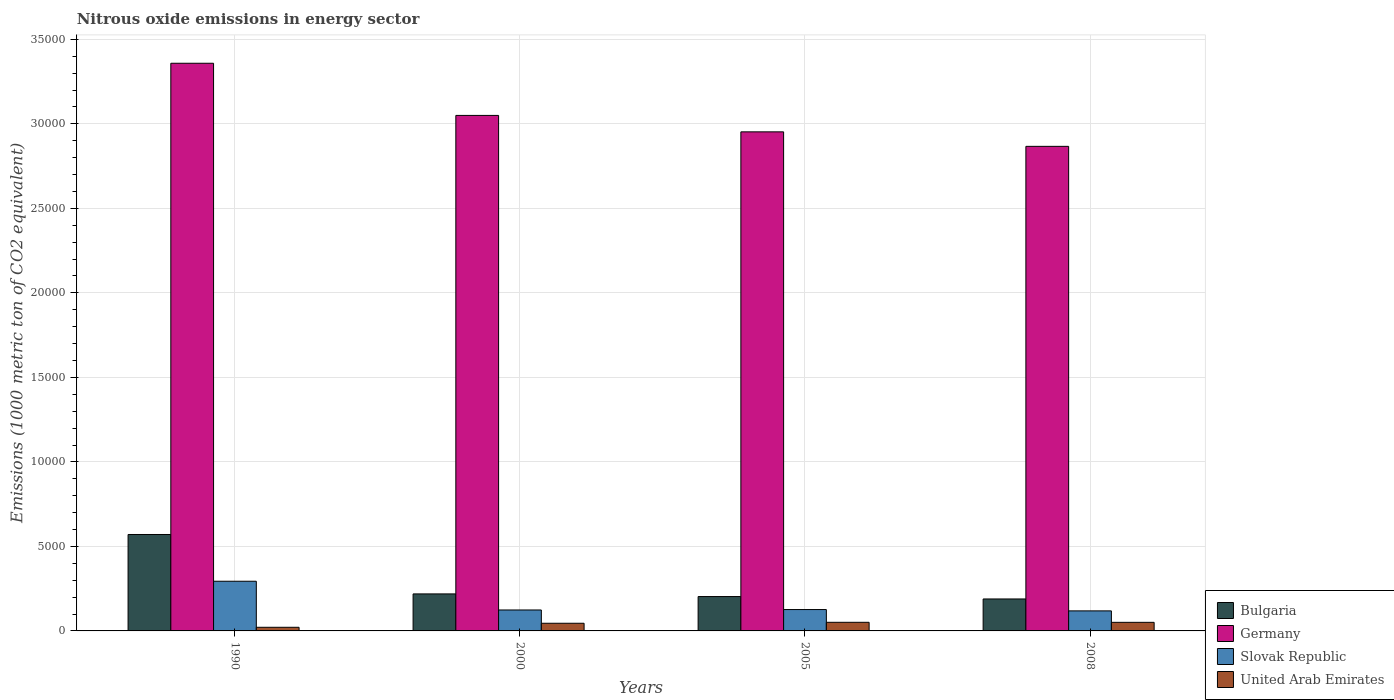How many bars are there on the 2nd tick from the right?
Provide a short and direct response. 4. What is the label of the 2nd group of bars from the left?
Provide a succinct answer. 2000. What is the amount of nitrous oxide emitted in United Arab Emirates in 2008?
Provide a short and direct response. 507.7. Across all years, what is the maximum amount of nitrous oxide emitted in Germany?
Your answer should be compact. 3.36e+04. Across all years, what is the minimum amount of nitrous oxide emitted in Slovak Republic?
Your answer should be compact. 1185.5. In which year was the amount of nitrous oxide emitted in United Arab Emirates maximum?
Provide a short and direct response. 2005. In which year was the amount of nitrous oxide emitted in Bulgaria minimum?
Ensure brevity in your answer.  2008. What is the total amount of nitrous oxide emitted in United Arab Emirates in the graph?
Provide a short and direct response. 1686. What is the difference between the amount of nitrous oxide emitted in Bulgaria in 1990 and that in 2008?
Your answer should be very brief. 3814.8. What is the difference between the amount of nitrous oxide emitted in United Arab Emirates in 2008 and the amount of nitrous oxide emitted in Slovak Republic in 2005?
Give a very brief answer. -756.8. What is the average amount of nitrous oxide emitted in United Arab Emirates per year?
Your answer should be very brief. 421.5. In the year 2005, what is the difference between the amount of nitrous oxide emitted in Bulgaria and amount of nitrous oxide emitted in Germany?
Offer a very short reply. -2.75e+04. In how many years, is the amount of nitrous oxide emitted in Germany greater than 10000 1000 metric ton?
Your answer should be compact. 4. What is the ratio of the amount of nitrous oxide emitted in Slovak Republic in 2000 to that in 2005?
Keep it short and to the point. 0.98. Is the amount of nitrous oxide emitted in United Arab Emirates in 1990 less than that in 2005?
Your answer should be very brief. Yes. What is the difference between the highest and the second highest amount of nitrous oxide emitted in United Arab Emirates?
Ensure brevity in your answer.  2.5. What is the difference between the highest and the lowest amount of nitrous oxide emitted in Bulgaria?
Your answer should be compact. 3814.8. In how many years, is the amount of nitrous oxide emitted in Slovak Republic greater than the average amount of nitrous oxide emitted in Slovak Republic taken over all years?
Your answer should be compact. 1. Is the sum of the amount of nitrous oxide emitted in United Arab Emirates in 2005 and 2008 greater than the maximum amount of nitrous oxide emitted in Bulgaria across all years?
Keep it short and to the point. No. What does the 3rd bar from the left in 2005 represents?
Offer a terse response. Slovak Republic. What does the 3rd bar from the right in 2008 represents?
Provide a short and direct response. Germany. Are all the bars in the graph horizontal?
Ensure brevity in your answer.  No. What is the difference between two consecutive major ticks on the Y-axis?
Give a very brief answer. 5000. Does the graph contain any zero values?
Ensure brevity in your answer.  No. Does the graph contain grids?
Ensure brevity in your answer.  Yes. Where does the legend appear in the graph?
Ensure brevity in your answer.  Bottom right. How many legend labels are there?
Offer a terse response. 4. What is the title of the graph?
Offer a terse response. Nitrous oxide emissions in energy sector. What is the label or title of the X-axis?
Provide a short and direct response. Years. What is the label or title of the Y-axis?
Provide a succinct answer. Emissions (1000 metric ton of CO2 equivalent). What is the Emissions (1000 metric ton of CO2 equivalent) of Bulgaria in 1990?
Make the answer very short. 5705.4. What is the Emissions (1000 metric ton of CO2 equivalent) in Germany in 1990?
Ensure brevity in your answer.  3.36e+04. What is the Emissions (1000 metric ton of CO2 equivalent) of Slovak Republic in 1990?
Give a very brief answer. 2939.5. What is the Emissions (1000 metric ton of CO2 equivalent) in United Arab Emirates in 1990?
Provide a short and direct response. 214.5. What is the Emissions (1000 metric ton of CO2 equivalent) in Bulgaria in 2000?
Give a very brief answer. 2189.9. What is the Emissions (1000 metric ton of CO2 equivalent) of Germany in 2000?
Keep it short and to the point. 3.05e+04. What is the Emissions (1000 metric ton of CO2 equivalent) in Slovak Republic in 2000?
Keep it short and to the point. 1239.1. What is the Emissions (1000 metric ton of CO2 equivalent) in United Arab Emirates in 2000?
Your answer should be very brief. 453.6. What is the Emissions (1000 metric ton of CO2 equivalent) in Bulgaria in 2005?
Make the answer very short. 2033.5. What is the Emissions (1000 metric ton of CO2 equivalent) of Germany in 2005?
Offer a very short reply. 2.95e+04. What is the Emissions (1000 metric ton of CO2 equivalent) in Slovak Republic in 2005?
Ensure brevity in your answer.  1264.5. What is the Emissions (1000 metric ton of CO2 equivalent) in United Arab Emirates in 2005?
Provide a succinct answer. 510.2. What is the Emissions (1000 metric ton of CO2 equivalent) of Bulgaria in 2008?
Keep it short and to the point. 1890.6. What is the Emissions (1000 metric ton of CO2 equivalent) of Germany in 2008?
Make the answer very short. 2.87e+04. What is the Emissions (1000 metric ton of CO2 equivalent) of Slovak Republic in 2008?
Offer a very short reply. 1185.5. What is the Emissions (1000 metric ton of CO2 equivalent) of United Arab Emirates in 2008?
Keep it short and to the point. 507.7. Across all years, what is the maximum Emissions (1000 metric ton of CO2 equivalent) of Bulgaria?
Give a very brief answer. 5705.4. Across all years, what is the maximum Emissions (1000 metric ton of CO2 equivalent) in Germany?
Keep it short and to the point. 3.36e+04. Across all years, what is the maximum Emissions (1000 metric ton of CO2 equivalent) in Slovak Republic?
Give a very brief answer. 2939.5. Across all years, what is the maximum Emissions (1000 metric ton of CO2 equivalent) of United Arab Emirates?
Offer a terse response. 510.2. Across all years, what is the minimum Emissions (1000 metric ton of CO2 equivalent) of Bulgaria?
Keep it short and to the point. 1890.6. Across all years, what is the minimum Emissions (1000 metric ton of CO2 equivalent) of Germany?
Your answer should be very brief. 2.87e+04. Across all years, what is the minimum Emissions (1000 metric ton of CO2 equivalent) of Slovak Republic?
Your answer should be compact. 1185.5. Across all years, what is the minimum Emissions (1000 metric ton of CO2 equivalent) of United Arab Emirates?
Make the answer very short. 214.5. What is the total Emissions (1000 metric ton of CO2 equivalent) of Bulgaria in the graph?
Offer a terse response. 1.18e+04. What is the total Emissions (1000 metric ton of CO2 equivalent) of Germany in the graph?
Offer a very short reply. 1.22e+05. What is the total Emissions (1000 metric ton of CO2 equivalent) of Slovak Republic in the graph?
Offer a very short reply. 6628.6. What is the total Emissions (1000 metric ton of CO2 equivalent) in United Arab Emirates in the graph?
Provide a short and direct response. 1686. What is the difference between the Emissions (1000 metric ton of CO2 equivalent) of Bulgaria in 1990 and that in 2000?
Your answer should be very brief. 3515.5. What is the difference between the Emissions (1000 metric ton of CO2 equivalent) in Germany in 1990 and that in 2000?
Make the answer very short. 3086.2. What is the difference between the Emissions (1000 metric ton of CO2 equivalent) of Slovak Republic in 1990 and that in 2000?
Ensure brevity in your answer.  1700.4. What is the difference between the Emissions (1000 metric ton of CO2 equivalent) of United Arab Emirates in 1990 and that in 2000?
Provide a short and direct response. -239.1. What is the difference between the Emissions (1000 metric ton of CO2 equivalent) of Bulgaria in 1990 and that in 2005?
Your answer should be compact. 3671.9. What is the difference between the Emissions (1000 metric ton of CO2 equivalent) in Germany in 1990 and that in 2005?
Your answer should be very brief. 4058.7. What is the difference between the Emissions (1000 metric ton of CO2 equivalent) of Slovak Republic in 1990 and that in 2005?
Provide a short and direct response. 1675. What is the difference between the Emissions (1000 metric ton of CO2 equivalent) in United Arab Emirates in 1990 and that in 2005?
Your answer should be compact. -295.7. What is the difference between the Emissions (1000 metric ton of CO2 equivalent) of Bulgaria in 1990 and that in 2008?
Make the answer very short. 3814.8. What is the difference between the Emissions (1000 metric ton of CO2 equivalent) of Germany in 1990 and that in 2008?
Give a very brief answer. 4916.5. What is the difference between the Emissions (1000 metric ton of CO2 equivalent) of Slovak Republic in 1990 and that in 2008?
Ensure brevity in your answer.  1754. What is the difference between the Emissions (1000 metric ton of CO2 equivalent) of United Arab Emirates in 1990 and that in 2008?
Ensure brevity in your answer.  -293.2. What is the difference between the Emissions (1000 metric ton of CO2 equivalent) of Bulgaria in 2000 and that in 2005?
Ensure brevity in your answer.  156.4. What is the difference between the Emissions (1000 metric ton of CO2 equivalent) of Germany in 2000 and that in 2005?
Offer a terse response. 972.5. What is the difference between the Emissions (1000 metric ton of CO2 equivalent) of Slovak Republic in 2000 and that in 2005?
Your answer should be compact. -25.4. What is the difference between the Emissions (1000 metric ton of CO2 equivalent) in United Arab Emirates in 2000 and that in 2005?
Give a very brief answer. -56.6. What is the difference between the Emissions (1000 metric ton of CO2 equivalent) in Bulgaria in 2000 and that in 2008?
Offer a terse response. 299.3. What is the difference between the Emissions (1000 metric ton of CO2 equivalent) in Germany in 2000 and that in 2008?
Offer a very short reply. 1830.3. What is the difference between the Emissions (1000 metric ton of CO2 equivalent) in Slovak Republic in 2000 and that in 2008?
Ensure brevity in your answer.  53.6. What is the difference between the Emissions (1000 metric ton of CO2 equivalent) of United Arab Emirates in 2000 and that in 2008?
Your answer should be compact. -54.1. What is the difference between the Emissions (1000 metric ton of CO2 equivalent) of Bulgaria in 2005 and that in 2008?
Provide a succinct answer. 142.9. What is the difference between the Emissions (1000 metric ton of CO2 equivalent) in Germany in 2005 and that in 2008?
Make the answer very short. 857.8. What is the difference between the Emissions (1000 metric ton of CO2 equivalent) in Slovak Republic in 2005 and that in 2008?
Ensure brevity in your answer.  79. What is the difference between the Emissions (1000 metric ton of CO2 equivalent) of Bulgaria in 1990 and the Emissions (1000 metric ton of CO2 equivalent) of Germany in 2000?
Your answer should be compact. -2.48e+04. What is the difference between the Emissions (1000 metric ton of CO2 equivalent) in Bulgaria in 1990 and the Emissions (1000 metric ton of CO2 equivalent) in Slovak Republic in 2000?
Keep it short and to the point. 4466.3. What is the difference between the Emissions (1000 metric ton of CO2 equivalent) of Bulgaria in 1990 and the Emissions (1000 metric ton of CO2 equivalent) of United Arab Emirates in 2000?
Ensure brevity in your answer.  5251.8. What is the difference between the Emissions (1000 metric ton of CO2 equivalent) of Germany in 1990 and the Emissions (1000 metric ton of CO2 equivalent) of Slovak Republic in 2000?
Make the answer very short. 3.23e+04. What is the difference between the Emissions (1000 metric ton of CO2 equivalent) in Germany in 1990 and the Emissions (1000 metric ton of CO2 equivalent) in United Arab Emirates in 2000?
Your answer should be very brief. 3.31e+04. What is the difference between the Emissions (1000 metric ton of CO2 equivalent) in Slovak Republic in 1990 and the Emissions (1000 metric ton of CO2 equivalent) in United Arab Emirates in 2000?
Your answer should be very brief. 2485.9. What is the difference between the Emissions (1000 metric ton of CO2 equivalent) of Bulgaria in 1990 and the Emissions (1000 metric ton of CO2 equivalent) of Germany in 2005?
Make the answer very short. -2.38e+04. What is the difference between the Emissions (1000 metric ton of CO2 equivalent) of Bulgaria in 1990 and the Emissions (1000 metric ton of CO2 equivalent) of Slovak Republic in 2005?
Your answer should be very brief. 4440.9. What is the difference between the Emissions (1000 metric ton of CO2 equivalent) of Bulgaria in 1990 and the Emissions (1000 metric ton of CO2 equivalent) of United Arab Emirates in 2005?
Offer a very short reply. 5195.2. What is the difference between the Emissions (1000 metric ton of CO2 equivalent) of Germany in 1990 and the Emissions (1000 metric ton of CO2 equivalent) of Slovak Republic in 2005?
Your response must be concise. 3.23e+04. What is the difference between the Emissions (1000 metric ton of CO2 equivalent) of Germany in 1990 and the Emissions (1000 metric ton of CO2 equivalent) of United Arab Emirates in 2005?
Offer a terse response. 3.31e+04. What is the difference between the Emissions (1000 metric ton of CO2 equivalent) of Slovak Republic in 1990 and the Emissions (1000 metric ton of CO2 equivalent) of United Arab Emirates in 2005?
Make the answer very short. 2429.3. What is the difference between the Emissions (1000 metric ton of CO2 equivalent) in Bulgaria in 1990 and the Emissions (1000 metric ton of CO2 equivalent) in Germany in 2008?
Provide a short and direct response. -2.30e+04. What is the difference between the Emissions (1000 metric ton of CO2 equivalent) of Bulgaria in 1990 and the Emissions (1000 metric ton of CO2 equivalent) of Slovak Republic in 2008?
Give a very brief answer. 4519.9. What is the difference between the Emissions (1000 metric ton of CO2 equivalent) of Bulgaria in 1990 and the Emissions (1000 metric ton of CO2 equivalent) of United Arab Emirates in 2008?
Ensure brevity in your answer.  5197.7. What is the difference between the Emissions (1000 metric ton of CO2 equivalent) of Germany in 1990 and the Emissions (1000 metric ton of CO2 equivalent) of Slovak Republic in 2008?
Offer a terse response. 3.24e+04. What is the difference between the Emissions (1000 metric ton of CO2 equivalent) of Germany in 1990 and the Emissions (1000 metric ton of CO2 equivalent) of United Arab Emirates in 2008?
Make the answer very short. 3.31e+04. What is the difference between the Emissions (1000 metric ton of CO2 equivalent) in Slovak Republic in 1990 and the Emissions (1000 metric ton of CO2 equivalent) in United Arab Emirates in 2008?
Give a very brief answer. 2431.8. What is the difference between the Emissions (1000 metric ton of CO2 equivalent) in Bulgaria in 2000 and the Emissions (1000 metric ton of CO2 equivalent) in Germany in 2005?
Offer a very short reply. -2.73e+04. What is the difference between the Emissions (1000 metric ton of CO2 equivalent) of Bulgaria in 2000 and the Emissions (1000 metric ton of CO2 equivalent) of Slovak Republic in 2005?
Ensure brevity in your answer.  925.4. What is the difference between the Emissions (1000 metric ton of CO2 equivalent) of Bulgaria in 2000 and the Emissions (1000 metric ton of CO2 equivalent) of United Arab Emirates in 2005?
Give a very brief answer. 1679.7. What is the difference between the Emissions (1000 metric ton of CO2 equivalent) in Germany in 2000 and the Emissions (1000 metric ton of CO2 equivalent) in Slovak Republic in 2005?
Give a very brief answer. 2.92e+04. What is the difference between the Emissions (1000 metric ton of CO2 equivalent) of Germany in 2000 and the Emissions (1000 metric ton of CO2 equivalent) of United Arab Emirates in 2005?
Offer a very short reply. 3.00e+04. What is the difference between the Emissions (1000 metric ton of CO2 equivalent) of Slovak Republic in 2000 and the Emissions (1000 metric ton of CO2 equivalent) of United Arab Emirates in 2005?
Keep it short and to the point. 728.9. What is the difference between the Emissions (1000 metric ton of CO2 equivalent) in Bulgaria in 2000 and the Emissions (1000 metric ton of CO2 equivalent) in Germany in 2008?
Your answer should be compact. -2.65e+04. What is the difference between the Emissions (1000 metric ton of CO2 equivalent) in Bulgaria in 2000 and the Emissions (1000 metric ton of CO2 equivalent) in Slovak Republic in 2008?
Provide a succinct answer. 1004.4. What is the difference between the Emissions (1000 metric ton of CO2 equivalent) of Bulgaria in 2000 and the Emissions (1000 metric ton of CO2 equivalent) of United Arab Emirates in 2008?
Make the answer very short. 1682.2. What is the difference between the Emissions (1000 metric ton of CO2 equivalent) of Germany in 2000 and the Emissions (1000 metric ton of CO2 equivalent) of Slovak Republic in 2008?
Your answer should be very brief. 2.93e+04. What is the difference between the Emissions (1000 metric ton of CO2 equivalent) in Germany in 2000 and the Emissions (1000 metric ton of CO2 equivalent) in United Arab Emirates in 2008?
Provide a short and direct response. 3.00e+04. What is the difference between the Emissions (1000 metric ton of CO2 equivalent) in Slovak Republic in 2000 and the Emissions (1000 metric ton of CO2 equivalent) in United Arab Emirates in 2008?
Your answer should be compact. 731.4. What is the difference between the Emissions (1000 metric ton of CO2 equivalent) of Bulgaria in 2005 and the Emissions (1000 metric ton of CO2 equivalent) of Germany in 2008?
Keep it short and to the point. -2.66e+04. What is the difference between the Emissions (1000 metric ton of CO2 equivalent) in Bulgaria in 2005 and the Emissions (1000 metric ton of CO2 equivalent) in Slovak Republic in 2008?
Ensure brevity in your answer.  848. What is the difference between the Emissions (1000 metric ton of CO2 equivalent) of Bulgaria in 2005 and the Emissions (1000 metric ton of CO2 equivalent) of United Arab Emirates in 2008?
Offer a very short reply. 1525.8. What is the difference between the Emissions (1000 metric ton of CO2 equivalent) of Germany in 2005 and the Emissions (1000 metric ton of CO2 equivalent) of Slovak Republic in 2008?
Ensure brevity in your answer.  2.83e+04. What is the difference between the Emissions (1000 metric ton of CO2 equivalent) in Germany in 2005 and the Emissions (1000 metric ton of CO2 equivalent) in United Arab Emirates in 2008?
Keep it short and to the point. 2.90e+04. What is the difference between the Emissions (1000 metric ton of CO2 equivalent) in Slovak Republic in 2005 and the Emissions (1000 metric ton of CO2 equivalent) in United Arab Emirates in 2008?
Give a very brief answer. 756.8. What is the average Emissions (1000 metric ton of CO2 equivalent) in Bulgaria per year?
Keep it short and to the point. 2954.85. What is the average Emissions (1000 metric ton of CO2 equivalent) in Germany per year?
Make the answer very short. 3.06e+04. What is the average Emissions (1000 metric ton of CO2 equivalent) in Slovak Republic per year?
Provide a succinct answer. 1657.15. What is the average Emissions (1000 metric ton of CO2 equivalent) of United Arab Emirates per year?
Provide a short and direct response. 421.5. In the year 1990, what is the difference between the Emissions (1000 metric ton of CO2 equivalent) in Bulgaria and Emissions (1000 metric ton of CO2 equivalent) in Germany?
Provide a succinct answer. -2.79e+04. In the year 1990, what is the difference between the Emissions (1000 metric ton of CO2 equivalent) of Bulgaria and Emissions (1000 metric ton of CO2 equivalent) of Slovak Republic?
Provide a short and direct response. 2765.9. In the year 1990, what is the difference between the Emissions (1000 metric ton of CO2 equivalent) in Bulgaria and Emissions (1000 metric ton of CO2 equivalent) in United Arab Emirates?
Give a very brief answer. 5490.9. In the year 1990, what is the difference between the Emissions (1000 metric ton of CO2 equivalent) of Germany and Emissions (1000 metric ton of CO2 equivalent) of Slovak Republic?
Ensure brevity in your answer.  3.06e+04. In the year 1990, what is the difference between the Emissions (1000 metric ton of CO2 equivalent) of Germany and Emissions (1000 metric ton of CO2 equivalent) of United Arab Emirates?
Ensure brevity in your answer.  3.34e+04. In the year 1990, what is the difference between the Emissions (1000 metric ton of CO2 equivalent) in Slovak Republic and Emissions (1000 metric ton of CO2 equivalent) in United Arab Emirates?
Keep it short and to the point. 2725. In the year 2000, what is the difference between the Emissions (1000 metric ton of CO2 equivalent) of Bulgaria and Emissions (1000 metric ton of CO2 equivalent) of Germany?
Ensure brevity in your answer.  -2.83e+04. In the year 2000, what is the difference between the Emissions (1000 metric ton of CO2 equivalent) in Bulgaria and Emissions (1000 metric ton of CO2 equivalent) in Slovak Republic?
Provide a short and direct response. 950.8. In the year 2000, what is the difference between the Emissions (1000 metric ton of CO2 equivalent) in Bulgaria and Emissions (1000 metric ton of CO2 equivalent) in United Arab Emirates?
Your answer should be very brief. 1736.3. In the year 2000, what is the difference between the Emissions (1000 metric ton of CO2 equivalent) of Germany and Emissions (1000 metric ton of CO2 equivalent) of Slovak Republic?
Your response must be concise. 2.93e+04. In the year 2000, what is the difference between the Emissions (1000 metric ton of CO2 equivalent) of Germany and Emissions (1000 metric ton of CO2 equivalent) of United Arab Emirates?
Your answer should be compact. 3.00e+04. In the year 2000, what is the difference between the Emissions (1000 metric ton of CO2 equivalent) in Slovak Republic and Emissions (1000 metric ton of CO2 equivalent) in United Arab Emirates?
Ensure brevity in your answer.  785.5. In the year 2005, what is the difference between the Emissions (1000 metric ton of CO2 equivalent) in Bulgaria and Emissions (1000 metric ton of CO2 equivalent) in Germany?
Offer a very short reply. -2.75e+04. In the year 2005, what is the difference between the Emissions (1000 metric ton of CO2 equivalent) in Bulgaria and Emissions (1000 metric ton of CO2 equivalent) in Slovak Republic?
Your answer should be very brief. 769. In the year 2005, what is the difference between the Emissions (1000 metric ton of CO2 equivalent) in Bulgaria and Emissions (1000 metric ton of CO2 equivalent) in United Arab Emirates?
Keep it short and to the point. 1523.3. In the year 2005, what is the difference between the Emissions (1000 metric ton of CO2 equivalent) of Germany and Emissions (1000 metric ton of CO2 equivalent) of Slovak Republic?
Keep it short and to the point. 2.83e+04. In the year 2005, what is the difference between the Emissions (1000 metric ton of CO2 equivalent) in Germany and Emissions (1000 metric ton of CO2 equivalent) in United Arab Emirates?
Keep it short and to the point. 2.90e+04. In the year 2005, what is the difference between the Emissions (1000 metric ton of CO2 equivalent) of Slovak Republic and Emissions (1000 metric ton of CO2 equivalent) of United Arab Emirates?
Your answer should be compact. 754.3. In the year 2008, what is the difference between the Emissions (1000 metric ton of CO2 equivalent) in Bulgaria and Emissions (1000 metric ton of CO2 equivalent) in Germany?
Give a very brief answer. -2.68e+04. In the year 2008, what is the difference between the Emissions (1000 metric ton of CO2 equivalent) in Bulgaria and Emissions (1000 metric ton of CO2 equivalent) in Slovak Republic?
Make the answer very short. 705.1. In the year 2008, what is the difference between the Emissions (1000 metric ton of CO2 equivalent) in Bulgaria and Emissions (1000 metric ton of CO2 equivalent) in United Arab Emirates?
Ensure brevity in your answer.  1382.9. In the year 2008, what is the difference between the Emissions (1000 metric ton of CO2 equivalent) of Germany and Emissions (1000 metric ton of CO2 equivalent) of Slovak Republic?
Offer a very short reply. 2.75e+04. In the year 2008, what is the difference between the Emissions (1000 metric ton of CO2 equivalent) of Germany and Emissions (1000 metric ton of CO2 equivalent) of United Arab Emirates?
Your response must be concise. 2.82e+04. In the year 2008, what is the difference between the Emissions (1000 metric ton of CO2 equivalent) in Slovak Republic and Emissions (1000 metric ton of CO2 equivalent) in United Arab Emirates?
Your response must be concise. 677.8. What is the ratio of the Emissions (1000 metric ton of CO2 equivalent) of Bulgaria in 1990 to that in 2000?
Make the answer very short. 2.61. What is the ratio of the Emissions (1000 metric ton of CO2 equivalent) of Germany in 1990 to that in 2000?
Your response must be concise. 1.1. What is the ratio of the Emissions (1000 metric ton of CO2 equivalent) of Slovak Republic in 1990 to that in 2000?
Your answer should be compact. 2.37. What is the ratio of the Emissions (1000 metric ton of CO2 equivalent) of United Arab Emirates in 1990 to that in 2000?
Offer a very short reply. 0.47. What is the ratio of the Emissions (1000 metric ton of CO2 equivalent) in Bulgaria in 1990 to that in 2005?
Your answer should be very brief. 2.81. What is the ratio of the Emissions (1000 metric ton of CO2 equivalent) of Germany in 1990 to that in 2005?
Give a very brief answer. 1.14. What is the ratio of the Emissions (1000 metric ton of CO2 equivalent) in Slovak Republic in 1990 to that in 2005?
Ensure brevity in your answer.  2.32. What is the ratio of the Emissions (1000 metric ton of CO2 equivalent) in United Arab Emirates in 1990 to that in 2005?
Keep it short and to the point. 0.42. What is the ratio of the Emissions (1000 metric ton of CO2 equivalent) in Bulgaria in 1990 to that in 2008?
Your answer should be very brief. 3.02. What is the ratio of the Emissions (1000 metric ton of CO2 equivalent) of Germany in 1990 to that in 2008?
Offer a terse response. 1.17. What is the ratio of the Emissions (1000 metric ton of CO2 equivalent) in Slovak Republic in 1990 to that in 2008?
Provide a short and direct response. 2.48. What is the ratio of the Emissions (1000 metric ton of CO2 equivalent) in United Arab Emirates in 1990 to that in 2008?
Your response must be concise. 0.42. What is the ratio of the Emissions (1000 metric ton of CO2 equivalent) in Bulgaria in 2000 to that in 2005?
Your answer should be compact. 1.08. What is the ratio of the Emissions (1000 metric ton of CO2 equivalent) of Germany in 2000 to that in 2005?
Make the answer very short. 1.03. What is the ratio of the Emissions (1000 metric ton of CO2 equivalent) of Slovak Republic in 2000 to that in 2005?
Make the answer very short. 0.98. What is the ratio of the Emissions (1000 metric ton of CO2 equivalent) in United Arab Emirates in 2000 to that in 2005?
Provide a short and direct response. 0.89. What is the ratio of the Emissions (1000 metric ton of CO2 equivalent) of Bulgaria in 2000 to that in 2008?
Your answer should be very brief. 1.16. What is the ratio of the Emissions (1000 metric ton of CO2 equivalent) in Germany in 2000 to that in 2008?
Your answer should be very brief. 1.06. What is the ratio of the Emissions (1000 metric ton of CO2 equivalent) of Slovak Republic in 2000 to that in 2008?
Offer a very short reply. 1.05. What is the ratio of the Emissions (1000 metric ton of CO2 equivalent) of United Arab Emirates in 2000 to that in 2008?
Offer a terse response. 0.89. What is the ratio of the Emissions (1000 metric ton of CO2 equivalent) of Bulgaria in 2005 to that in 2008?
Ensure brevity in your answer.  1.08. What is the ratio of the Emissions (1000 metric ton of CO2 equivalent) of Germany in 2005 to that in 2008?
Keep it short and to the point. 1.03. What is the ratio of the Emissions (1000 metric ton of CO2 equivalent) of Slovak Republic in 2005 to that in 2008?
Offer a terse response. 1.07. What is the difference between the highest and the second highest Emissions (1000 metric ton of CO2 equivalent) of Bulgaria?
Offer a terse response. 3515.5. What is the difference between the highest and the second highest Emissions (1000 metric ton of CO2 equivalent) of Germany?
Offer a terse response. 3086.2. What is the difference between the highest and the second highest Emissions (1000 metric ton of CO2 equivalent) in Slovak Republic?
Provide a succinct answer. 1675. What is the difference between the highest and the lowest Emissions (1000 metric ton of CO2 equivalent) of Bulgaria?
Your response must be concise. 3814.8. What is the difference between the highest and the lowest Emissions (1000 metric ton of CO2 equivalent) of Germany?
Your answer should be compact. 4916.5. What is the difference between the highest and the lowest Emissions (1000 metric ton of CO2 equivalent) of Slovak Republic?
Provide a short and direct response. 1754. What is the difference between the highest and the lowest Emissions (1000 metric ton of CO2 equivalent) in United Arab Emirates?
Offer a very short reply. 295.7. 